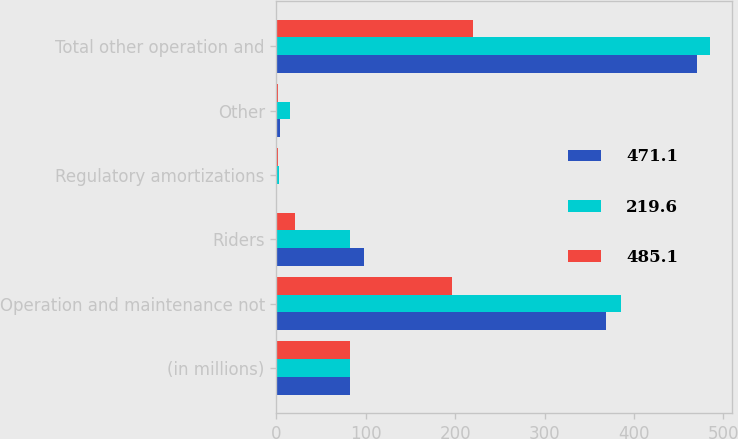<chart> <loc_0><loc_0><loc_500><loc_500><stacked_bar_chart><ecel><fcel>(in millions)<fcel>Operation and maintenance not<fcel>Riders<fcel>Regulatory amortizations<fcel>Other<fcel>Total other operation and<nl><fcel>471.1<fcel>82.3<fcel>368.4<fcel>98.1<fcel>1<fcel>3.6<fcel>471.1<nl><fcel>219.6<fcel>82.3<fcel>385.3<fcel>82.3<fcel>2.7<fcel>14.8<fcel>485.1<nl><fcel>485.1<fcel>82.3<fcel>196<fcel>20.2<fcel>1.3<fcel>2.1<fcel>219.6<nl></chart> 